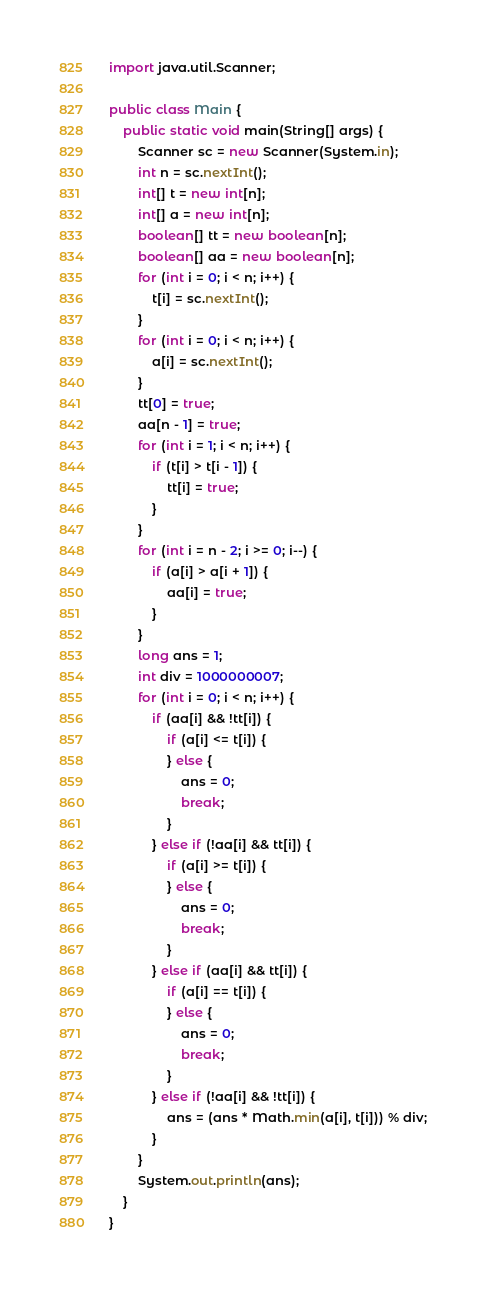Convert code to text. <code><loc_0><loc_0><loc_500><loc_500><_Java_>import java.util.Scanner;

public class Main {
	public static void main(String[] args) {
		Scanner sc = new Scanner(System.in);
		int n = sc.nextInt();
		int[] t = new int[n];
		int[] a = new int[n];
		boolean[] tt = new boolean[n];
		boolean[] aa = new boolean[n];
		for (int i = 0; i < n; i++) {
			t[i] = sc.nextInt();
		}
		for (int i = 0; i < n; i++) {
			a[i] = sc.nextInt();
		}
		tt[0] = true;
		aa[n - 1] = true;
		for (int i = 1; i < n; i++) {
			if (t[i] > t[i - 1]) {
				tt[i] = true;
			}
		}
		for (int i = n - 2; i >= 0; i--) {
			if (a[i] > a[i + 1]) {
				aa[i] = true;
			}
		}
		long ans = 1;
		int div = 1000000007;
		for (int i = 0; i < n; i++) {
			if (aa[i] && !tt[i]) {
				if (a[i] <= t[i]) {
				} else {
					ans = 0;
					break;
				}
			} else if (!aa[i] && tt[i]) {
				if (a[i] >= t[i]) {
				} else {
					ans = 0;
					break;
				}
			} else if (aa[i] && tt[i]) {
				if (a[i] == t[i]) {
				} else {
					ans = 0;
					break;
				}
			} else if (!aa[i] && !tt[i]) {
				ans = (ans * Math.min(a[i], t[i])) % div;
			}
		}
		System.out.println(ans);
	}
}
</code> 